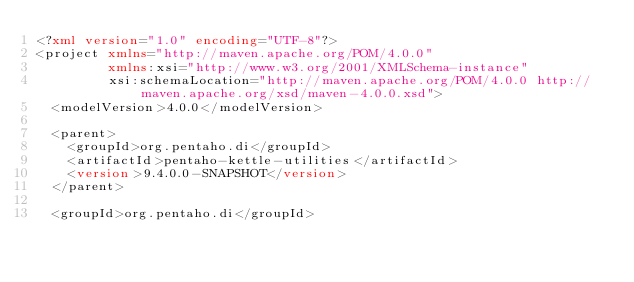<code> <loc_0><loc_0><loc_500><loc_500><_XML_><?xml version="1.0" encoding="UTF-8"?>
<project xmlns="http://maven.apache.org/POM/4.0.0"
         xmlns:xsi="http://www.w3.org/2001/XMLSchema-instance"
         xsi:schemaLocation="http://maven.apache.org/POM/4.0.0 http://maven.apache.org/xsd/maven-4.0.0.xsd">
  <modelVersion>4.0.0</modelVersion>

  <parent>
    <groupId>org.pentaho.di</groupId>
    <artifactId>pentaho-kettle-utilities</artifactId>
    <version>9.4.0.0-SNAPSHOT</version>
  </parent>

  <groupId>org.pentaho.di</groupId></code> 